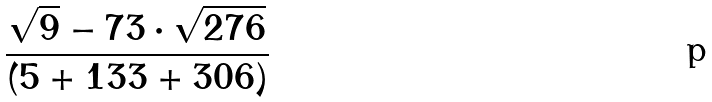<formula> <loc_0><loc_0><loc_500><loc_500>\frac { \sqrt { 9 } - 7 3 \cdot \sqrt { 2 7 6 } } { ( 5 + 1 3 3 + 3 0 6 ) }</formula> 